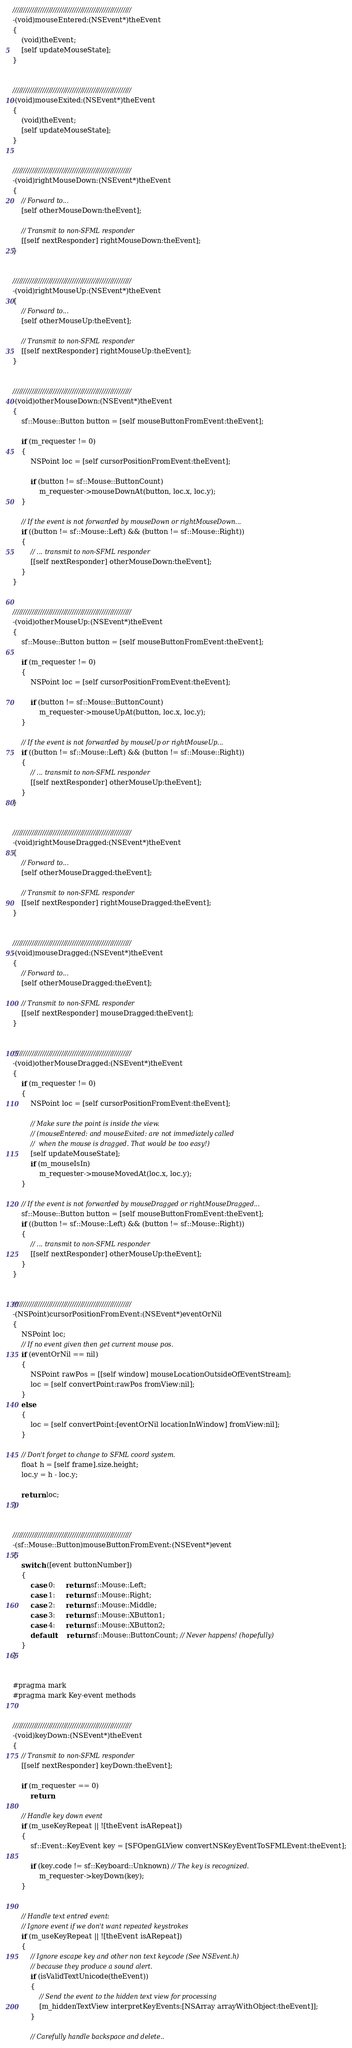Convert code to text. <code><loc_0><loc_0><loc_500><loc_500><_ObjectiveC_>
////////////////////////////////////////////////////////
-(void)mouseEntered:(NSEvent*)theEvent
{
    (void)theEvent;
    [self updateMouseState];
}


////////////////////////////////////////////////////////
-(void)mouseExited:(NSEvent*)theEvent
{
    (void)theEvent;
    [self updateMouseState];
}


////////////////////////////////////////////////////////
-(void)rightMouseDown:(NSEvent*)theEvent
{
    // Forward to...
    [self otherMouseDown:theEvent];

    // Transmit to non-SFML responder
    [[self nextResponder] rightMouseDown:theEvent];
}


////////////////////////////////////////////////////////
-(void)rightMouseUp:(NSEvent*)theEvent
{
    // Forward to...
    [self otherMouseUp:theEvent];

    // Transmit to non-SFML responder
    [[self nextResponder] rightMouseUp:theEvent];
}


////////////////////////////////////////////////////////
-(void)otherMouseDown:(NSEvent*)theEvent
{
    sf::Mouse::Button button = [self mouseButtonFromEvent:theEvent];

    if (m_requester != 0)
    {
        NSPoint loc = [self cursorPositionFromEvent:theEvent];

        if (button != sf::Mouse::ButtonCount)
            m_requester->mouseDownAt(button, loc.x, loc.y);
    }

    // If the event is not forwarded by mouseDown or rightMouseDown...
    if ((button != sf::Mouse::Left) && (button != sf::Mouse::Right))
    {
        // ... transmit to non-SFML responder
        [[self nextResponder] otherMouseDown:theEvent];
    }
}


////////////////////////////////////////////////////////
-(void)otherMouseUp:(NSEvent*)theEvent
{
    sf::Mouse::Button button = [self mouseButtonFromEvent:theEvent];

    if (m_requester != 0)
    {
        NSPoint loc = [self cursorPositionFromEvent:theEvent];

        if (button != sf::Mouse::ButtonCount)
            m_requester->mouseUpAt(button, loc.x, loc.y);
    }

    // If the event is not forwarded by mouseUp or rightMouseUp...
    if ((button != sf::Mouse::Left) && (button != sf::Mouse::Right))
    {
        // ... transmit to non-SFML responder
        [[self nextResponder] otherMouseUp:theEvent];
    }
}


////////////////////////////////////////////////////////
-(void)rightMouseDragged:(NSEvent*)theEvent
{
    // Forward to...
    [self otherMouseDragged:theEvent];

    // Transmit to non-SFML responder
    [[self nextResponder] rightMouseDragged:theEvent];
}


////////////////////////////////////////////////////////
-(void)mouseDragged:(NSEvent*)theEvent
{
    // Forward to...
    [self otherMouseDragged:theEvent];

    // Transmit to non-SFML responder
    [[self nextResponder] mouseDragged:theEvent];
}


////////////////////////////////////////////////////////
-(void)otherMouseDragged:(NSEvent*)theEvent
{
    if (m_requester != 0)
    {
        NSPoint loc = [self cursorPositionFromEvent:theEvent];

        // Make sure the point is inside the view.
        // (mouseEntered: and mouseExited: are not immediately called
        //  when the mouse is dragged. That would be too easy!)
        [self updateMouseState];
        if (m_mouseIsIn)
            m_requester->mouseMovedAt(loc.x, loc.y);
    }

    // If the event is not forwarded by mouseDragged or rightMouseDragged...
    sf::Mouse::Button button = [self mouseButtonFromEvent:theEvent];
    if ((button != sf::Mouse::Left) && (button != sf::Mouse::Right))
    {
        // ... transmit to non-SFML responder
        [[self nextResponder] otherMouseUp:theEvent];
    }
}


////////////////////////////////////////////////////////
-(NSPoint)cursorPositionFromEvent:(NSEvent*)eventOrNil
{
    NSPoint loc;
    // If no event given then get current mouse pos.
    if (eventOrNil == nil)
    {
        NSPoint rawPos = [[self window] mouseLocationOutsideOfEventStream];
        loc = [self convertPoint:rawPos fromView:nil];
    }
    else
    {
        loc = [self convertPoint:[eventOrNil locationInWindow] fromView:nil];
    }

    // Don't forget to change to SFML coord system.
    float h = [self frame].size.height;
    loc.y = h - loc.y;

    return loc;
}


////////////////////////////////////////////////////////
-(sf::Mouse::Button)mouseButtonFromEvent:(NSEvent*)event
{
    switch ([event buttonNumber])
    {
        case 0:     return sf::Mouse::Left;
        case 1:     return sf::Mouse::Right;
        case 2:     return sf::Mouse::Middle;
        case 3:     return sf::Mouse::XButton1;
        case 4:     return sf::Mouse::XButton2;
        default:    return sf::Mouse::ButtonCount; // Never happens! (hopefully)
    }
}


#pragma mark
#pragma mark Key-event methods


////////////////////////////////////////////////////////
-(void)keyDown:(NSEvent*)theEvent
{
    // Transmit to non-SFML responder
    [[self nextResponder] keyDown:theEvent];

    if (m_requester == 0)
        return;

    // Handle key down event
    if (m_useKeyRepeat || ![theEvent isARepeat])
    {
        sf::Event::KeyEvent key = [SFOpenGLView convertNSKeyEventToSFMLEvent:theEvent];

        if (key.code != sf::Keyboard::Unknown) // The key is recognized.
            m_requester->keyDown(key);
    }


    // Handle text entred event:
    // Ignore event if we don't want repeated keystrokes
    if (m_useKeyRepeat || ![theEvent isARepeat])
    {
        // Ignore escape key and other non text keycode (See NSEvent.h)
        // because they produce a sound alert.
        if (isValidTextUnicode(theEvent))
        {
            // Send the event to the hidden text view for processing
            [m_hiddenTextView interpretKeyEvents:[NSArray arrayWithObject:theEvent]];
        }

        // Carefully handle backspace and delete..</code> 